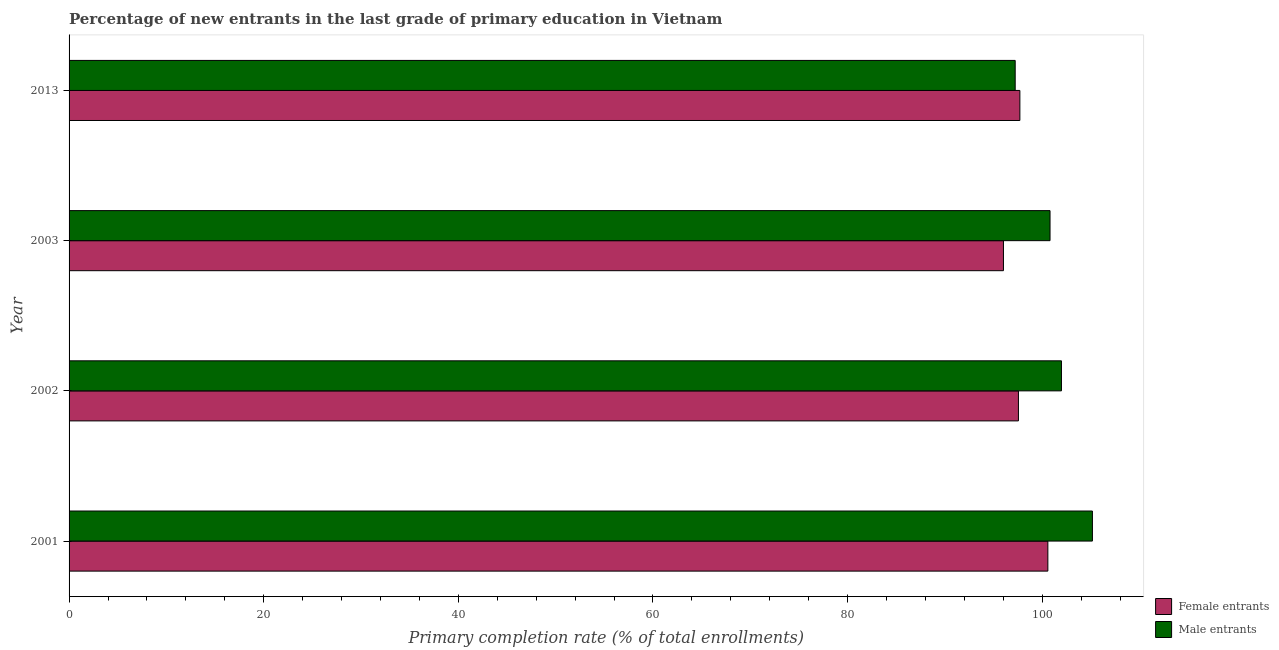Are the number of bars per tick equal to the number of legend labels?
Give a very brief answer. Yes. How many bars are there on the 1st tick from the top?
Provide a short and direct response. 2. What is the primary completion rate of female entrants in 2002?
Offer a very short reply. 97.55. Across all years, what is the maximum primary completion rate of male entrants?
Your response must be concise. 105.16. Across all years, what is the minimum primary completion rate of male entrants?
Keep it short and to the point. 97.22. In which year was the primary completion rate of female entrants minimum?
Your answer should be compact. 2003. What is the total primary completion rate of male entrants in the graph?
Your response must be concise. 405.15. What is the difference between the primary completion rate of female entrants in 2002 and that in 2003?
Ensure brevity in your answer.  1.54. What is the difference between the primary completion rate of female entrants in 2002 and the primary completion rate of male entrants in 2001?
Make the answer very short. -7.6. What is the average primary completion rate of male entrants per year?
Offer a terse response. 101.29. In the year 2013, what is the difference between the primary completion rate of female entrants and primary completion rate of male entrants?
Your response must be concise. 0.48. In how many years, is the primary completion rate of male entrants greater than 60 %?
Ensure brevity in your answer.  4. What is the ratio of the primary completion rate of male entrants in 2002 to that in 2003?
Keep it short and to the point. 1.01. Is the primary completion rate of female entrants in 2003 less than that in 2013?
Offer a terse response. Yes. Is the difference between the primary completion rate of female entrants in 2002 and 2003 greater than the difference between the primary completion rate of male entrants in 2002 and 2003?
Give a very brief answer. Yes. What is the difference between the highest and the second highest primary completion rate of male entrants?
Ensure brevity in your answer.  3.18. What is the difference between the highest and the lowest primary completion rate of male entrants?
Make the answer very short. 7.94. In how many years, is the primary completion rate of male entrants greater than the average primary completion rate of male entrants taken over all years?
Your answer should be compact. 2. What does the 1st bar from the top in 2001 represents?
Your response must be concise. Male entrants. What does the 2nd bar from the bottom in 2001 represents?
Give a very brief answer. Male entrants. How many bars are there?
Make the answer very short. 8. What is the difference between two consecutive major ticks on the X-axis?
Keep it short and to the point. 20. Are the values on the major ticks of X-axis written in scientific E-notation?
Provide a succinct answer. No. Does the graph contain any zero values?
Give a very brief answer. No. Does the graph contain grids?
Offer a very short reply. No. How many legend labels are there?
Offer a very short reply. 2. What is the title of the graph?
Make the answer very short. Percentage of new entrants in the last grade of primary education in Vietnam. Does "Net National savings" appear as one of the legend labels in the graph?
Provide a short and direct response. No. What is the label or title of the X-axis?
Provide a short and direct response. Primary completion rate (% of total enrollments). What is the Primary completion rate (% of total enrollments) of Female entrants in 2001?
Your answer should be very brief. 100.58. What is the Primary completion rate (% of total enrollments) of Male entrants in 2001?
Offer a terse response. 105.16. What is the Primary completion rate (% of total enrollments) of Female entrants in 2002?
Offer a very short reply. 97.55. What is the Primary completion rate (% of total enrollments) in Male entrants in 2002?
Ensure brevity in your answer.  101.97. What is the Primary completion rate (% of total enrollments) of Female entrants in 2003?
Offer a very short reply. 96.01. What is the Primary completion rate (% of total enrollments) in Male entrants in 2003?
Make the answer very short. 100.8. What is the Primary completion rate (% of total enrollments) in Female entrants in 2013?
Your response must be concise. 97.7. What is the Primary completion rate (% of total enrollments) in Male entrants in 2013?
Ensure brevity in your answer.  97.22. Across all years, what is the maximum Primary completion rate (% of total enrollments) in Female entrants?
Provide a succinct answer. 100.58. Across all years, what is the maximum Primary completion rate (% of total enrollments) in Male entrants?
Give a very brief answer. 105.16. Across all years, what is the minimum Primary completion rate (% of total enrollments) of Female entrants?
Make the answer very short. 96.01. Across all years, what is the minimum Primary completion rate (% of total enrollments) of Male entrants?
Offer a very short reply. 97.22. What is the total Primary completion rate (% of total enrollments) of Female entrants in the graph?
Provide a succinct answer. 391.84. What is the total Primary completion rate (% of total enrollments) of Male entrants in the graph?
Keep it short and to the point. 405.15. What is the difference between the Primary completion rate (% of total enrollments) in Female entrants in 2001 and that in 2002?
Make the answer very short. 3.02. What is the difference between the Primary completion rate (% of total enrollments) of Male entrants in 2001 and that in 2002?
Offer a terse response. 3.18. What is the difference between the Primary completion rate (% of total enrollments) in Female entrants in 2001 and that in 2003?
Provide a short and direct response. 4.56. What is the difference between the Primary completion rate (% of total enrollments) of Male entrants in 2001 and that in 2003?
Provide a short and direct response. 4.36. What is the difference between the Primary completion rate (% of total enrollments) of Female entrants in 2001 and that in 2013?
Provide a short and direct response. 2.88. What is the difference between the Primary completion rate (% of total enrollments) of Male entrants in 2001 and that in 2013?
Keep it short and to the point. 7.94. What is the difference between the Primary completion rate (% of total enrollments) of Female entrants in 2002 and that in 2003?
Your answer should be very brief. 1.54. What is the difference between the Primary completion rate (% of total enrollments) in Male entrants in 2002 and that in 2003?
Offer a very short reply. 1.17. What is the difference between the Primary completion rate (% of total enrollments) in Female entrants in 2002 and that in 2013?
Your answer should be compact. -0.15. What is the difference between the Primary completion rate (% of total enrollments) in Male entrants in 2002 and that in 2013?
Your answer should be very brief. 4.75. What is the difference between the Primary completion rate (% of total enrollments) of Female entrants in 2003 and that in 2013?
Provide a succinct answer. -1.69. What is the difference between the Primary completion rate (% of total enrollments) of Male entrants in 2003 and that in 2013?
Give a very brief answer. 3.58. What is the difference between the Primary completion rate (% of total enrollments) of Female entrants in 2001 and the Primary completion rate (% of total enrollments) of Male entrants in 2002?
Provide a short and direct response. -1.4. What is the difference between the Primary completion rate (% of total enrollments) in Female entrants in 2001 and the Primary completion rate (% of total enrollments) in Male entrants in 2003?
Give a very brief answer. -0.22. What is the difference between the Primary completion rate (% of total enrollments) of Female entrants in 2001 and the Primary completion rate (% of total enrollments) of Male entrants in 2013?
Offer a terse response. 3.36. What is the difference between the Primary completion rate (% of total enrollments) in Female entrants in 2002 and the Primary completion rate (% of total enrollments) in Male entrants in 2003?
Ensure brevity in your answer.  -3.25. What is the difference between the Primary completion rate (% of total enrollments) of Female entrants in 2002 and the Primary completion rate (% of total enrollments) of Male entrants in 2013?
Ensure brevity in your answer.  0.33. What is the difference between the Primary completion rate (% of total enrollments) in Female entrants in 2003 and the Primary completion rate (% of total enrollments) in Male entrants in 2013?
Provide a short and direct response. -1.21. What is the average Primary completion rate (% of total enrollments) of Female entrants per year?
Provide a succinct answer. 97.96. What is the average Primary completion rate (% of total enrollments) in Male entrants per year?
Offer a terse response. 101.29. In the year 2001, what is the difference between the Primary completion rate (% of total enrollments) in Female entrants and Primary completion rate (% of total enrollments) in Male entrants?
Your answer should be compact. -4.58. In the year 2002, what is the difference between the Primary completion rate (% of total enrollments) in Female entrants and Primary completion rate (% of total enrollments) in Male entrants?
Provide a short and direct response. -4.42. In the year 2003, what is the difference between the Primary completion rate (% of total enrollments) of Female entrants and Primary completion rate (% of total enrollments) of Male entrants?
Provide a short and direct response. -4.79. In the year 2013, what is the difference between the Primary completion rate (% of total enrollments) in Female entrants and Primary completion rate (% of total enrollments) in Male entrants?
Make the answer very short. 0.48. What is the ratio of the Primary completion rate (% of total enrollments) in Female entrants in 2001 to that in 2002?
Make the answer very short. 1.03. What is the ratio of the Primary completion rate (% of total enrollments) of Male entrants in 2001 to that in 2002?
Provide a succinct answer. 1.03. What is the ratio of the Primary completion rate (% of total enrollments) of Female entrants in 2001 to that in 2003?
Provide a short and direct response. 1.05. What is the ratio of the Primary completion rate (% of total enrollments) in Male entrants in 2001 to that in 2003?
Keep it short and to the point. 1.04. What is the ratio of the Primary completion rate (% of total enrollments) in Female entrants in 2001 to that in 2013?
Your response must be concise. 1.03. What is the ratio of the Primary completion rate (% of total enrollments) in Male entrants in 2001 to that in 2013?
Ensure brevity in your answer.  1.08. What is the ratio of the Primary completion rate (% of total enrollments) of Male entrants in 2002 to that in 2003?
Make the answer very short. 1.01. What is the ratio of the Primary completion rate (% of total enrollments) in Male entrants in 2002 to that in 2013?
Keep it short and to the point. 1.05. What is the ratio of the Primary completion rate (% of total enrollments) in Female entrants in 2003 to that in 2013?
Ensure brevity in your answer.  0.98. What is the ratio of the Primary completion rate (% of total enrollments) in Male entrants in 2003 to that in 2013?
Ensure brevity in your answer.  1.04. What is the difference between the highest and the second highest Primary completion rate (% of total enrollments) in Female entrants?
Provide a succinct answer. 2.88. What is the difference between the highest and the second highest Primary completion rate (% of total enrollments) in Male entrants?
Offer a very short reply. 3.18. What is the difference between the highest and the lowest Primary completion rate (% of total enrollments) in Female entrants?
Your response must be concise. 4.56. What is the difference between the highest and the lowest Primary completion rate (% of total enrollments) in Male entrants?
Ensure brevity in your answer.  7.94. 